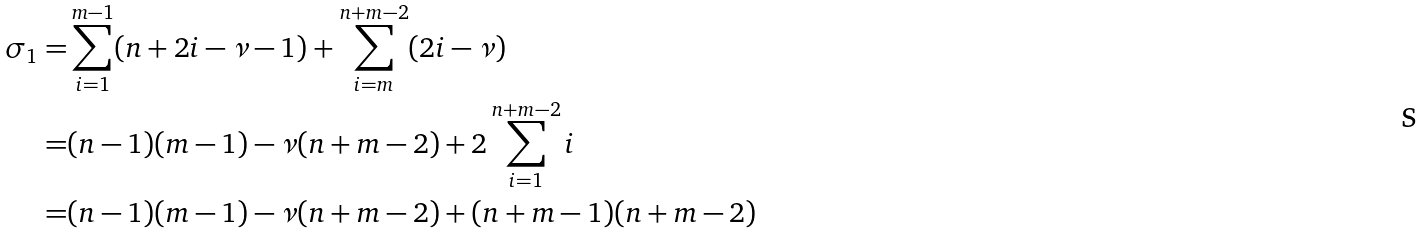Convert formula to latex. <formula><loc_0><loc_0><loc_500><loc_500>\sigma _ { 1 } = & \sum _ { i = 1 } ^ { m - 1 } ( n + 2 i - \nu - 1 ) + \sum _ { i = m } ^ { n + m - 2 } ( 2 i - \nu ) \\ = & ( n - 1 ) ( m - 1 ) - \nu ( n + m - 2 ) + 2 \sum _ { i = 1 } ^ { n + m - 2 } i \\ = & ( n - 1 ) ( m - 1 ) - \nu ( n + m - 2 ) + ( n + m - 1 ) ( n + m - 2 )</formula> 